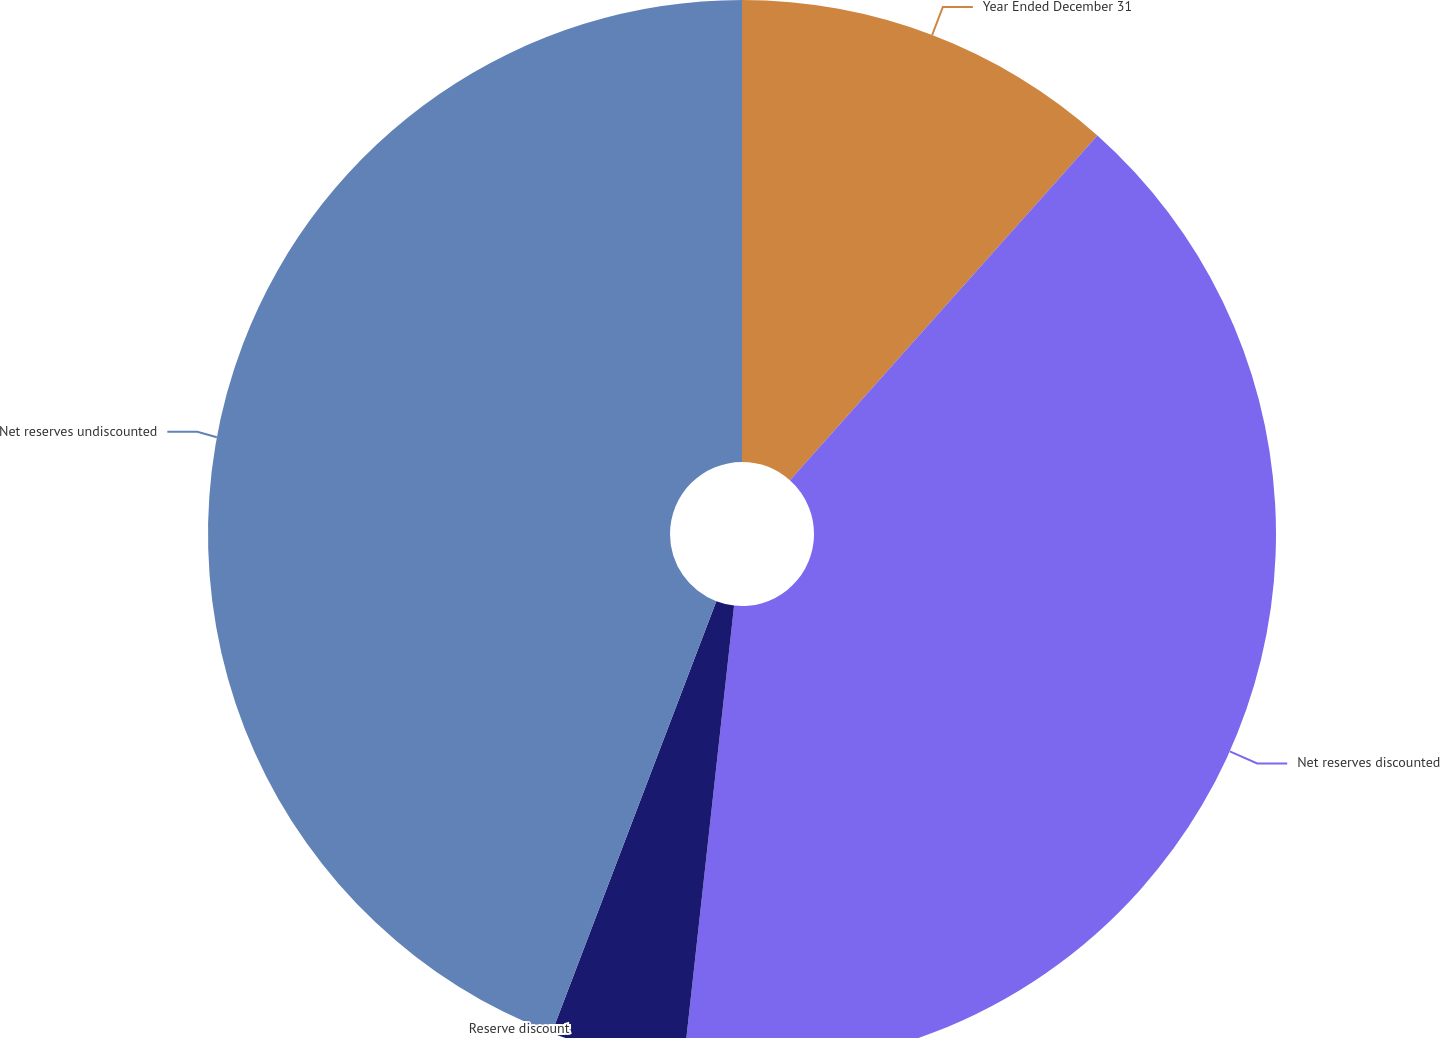Convert chart. <chart><loc_0><loc_0><loc_500><loc_500><pie_chart><fcel>Year Ended December 31<fcel>Net reserves discounted<fcel>Reserve discount<fcel>Net reserves undiscounted<nl><fcel>11.59%<fcel>40.16%<fcel>4.05%<fcel>44.2%<nl></chart> 